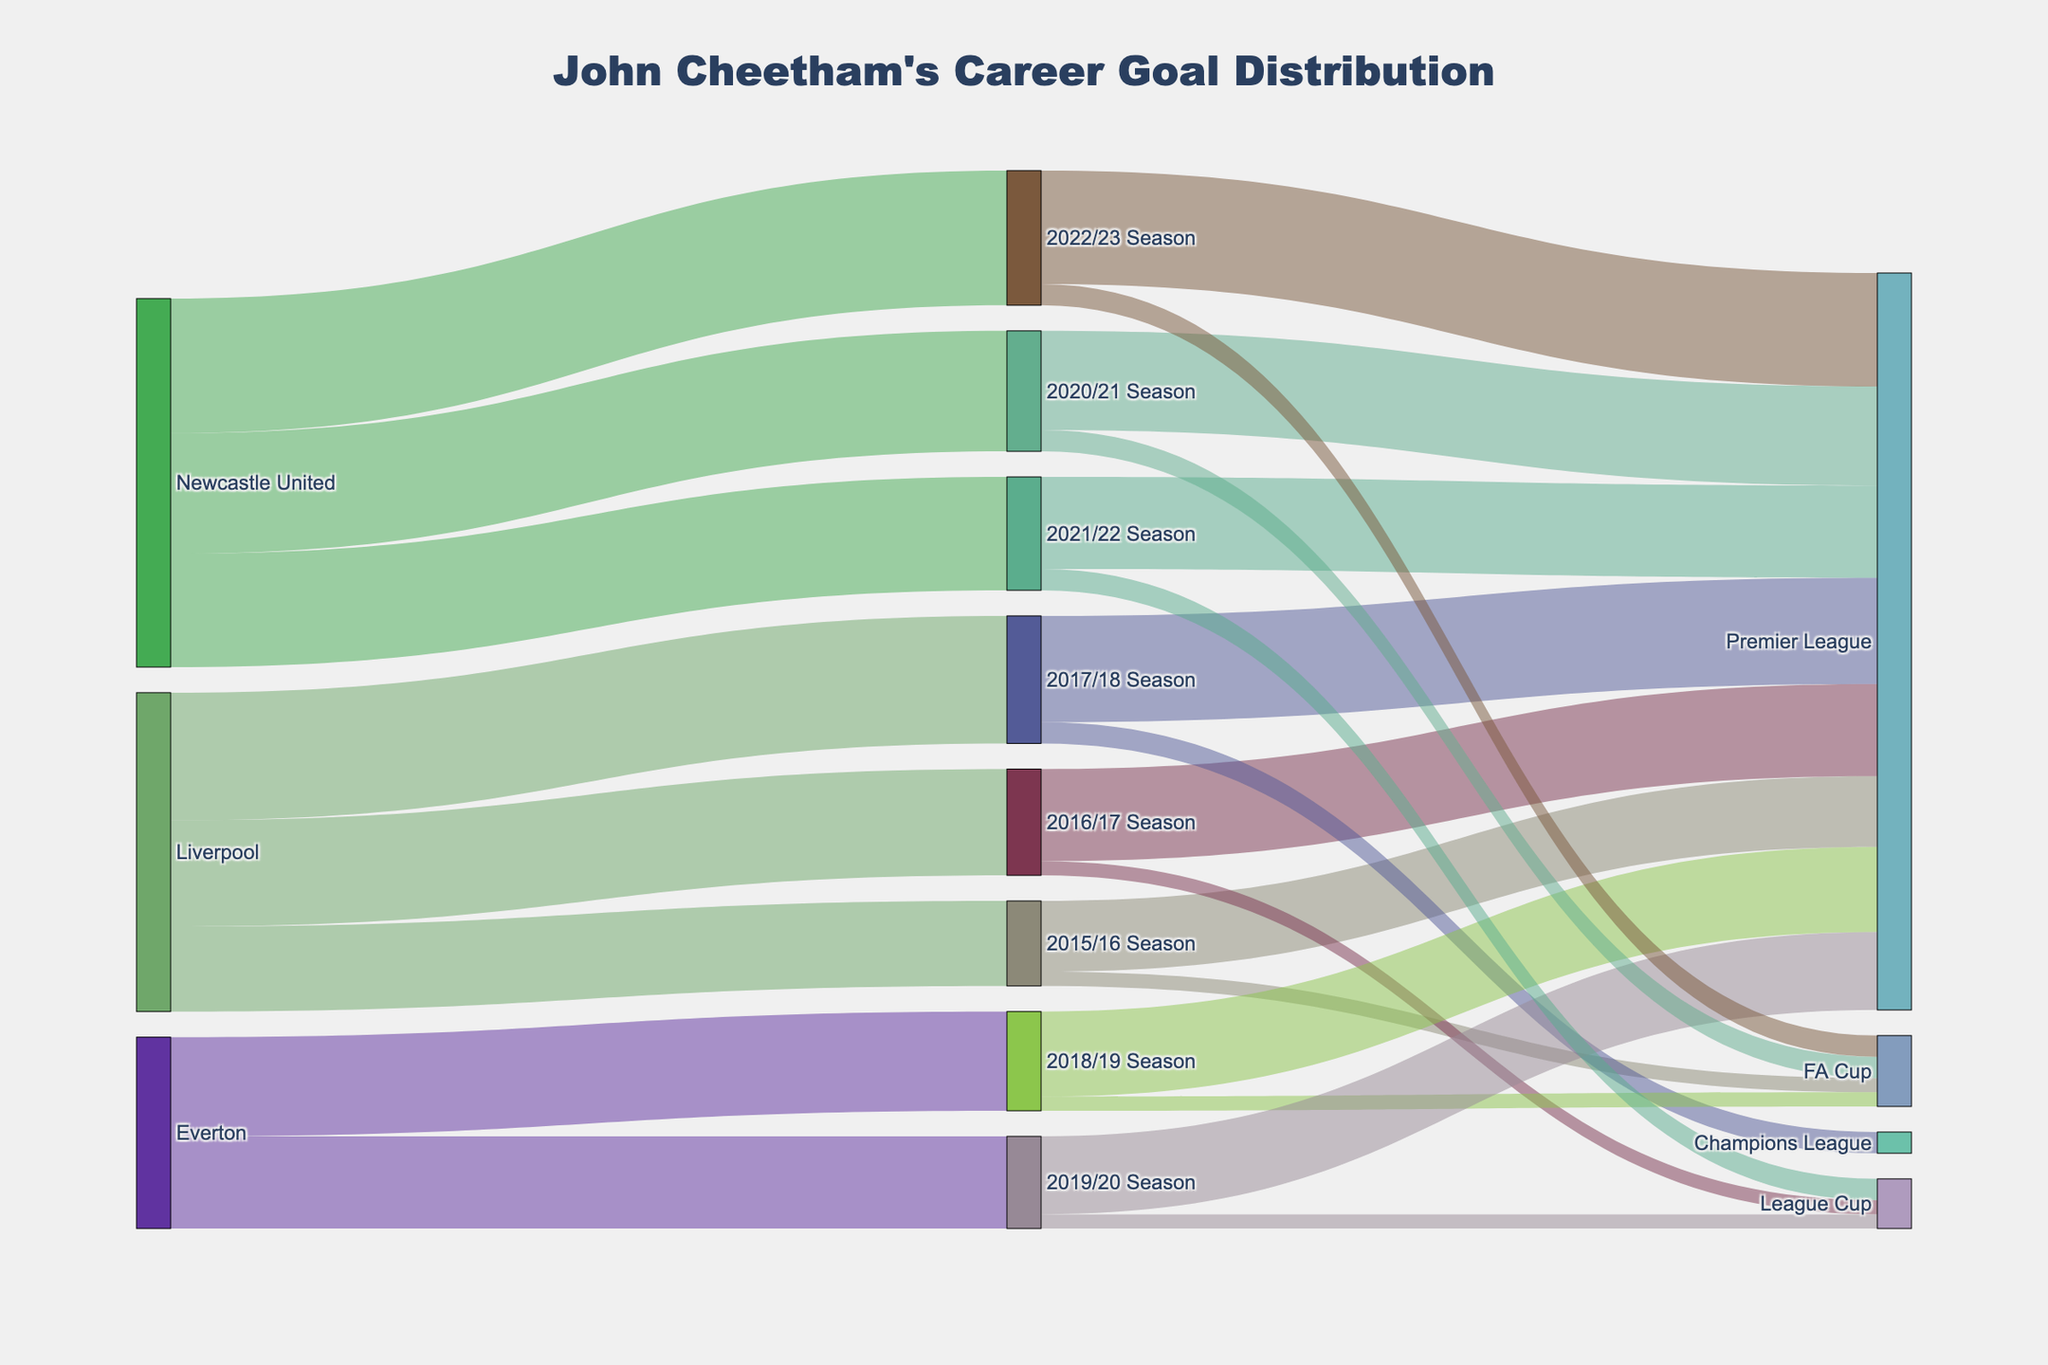What is the title of the Sankey Diagram? The title is usually found at the top of the figure. In this case, it is the main descriptor of the plot.
Answer: John Cheetham's Career Goal Distribution How many goals did John Cheetham score for Liverpool in the 2017/18 season? Referring to the specific flow from Liverpool to the 2017/18 season in the Sankey Diagram, the value indicated is 18 goals.
Answer: 18 Which season did John Cheetham score the highest number of Premier League goals? The Sankey Diagram shows the flows from seasons to different competitions. By looking for the highest value going to the Premier League from each season’s node, you find that the 2022/23 Season has the highest value with 16 goals.
Answer: 2022/23 Season How many total goals did John Cheetham score during his time with Everton? Sum the goals from the nodes Everton to the 2018/19 and 2019/20 seasons: 14 + 13 = 27 goals.
Answer: 27 In which competition did John Cheetham score the fewest goals in any single season? By noting the flows going to different competitions from each season's node, the smallest values are 2 goals each, in the FA Cup (2015/16 and 2018/19) and League Cup (2016/17 and 2019/20).
Answer: FA Cup (2015/16, 2018/19), League Cup (2016/17, 2019/20) How does the number of FA Cup goals in the 2022/23 season compare to the number of goals in the FA Cup in the 2020/21 season? Locate the flows from 2022/23 Season and 2020/21 Season to the FA Cup node, where the values are 3 goals each. They are equal.
Answer: They are equal What is the average number of goals John Cheetham scored per season across all seasons? Add all the goals across seasons (12 + 15 + 18 + 14 + 13 + 17 + 16 + 19 = 124) and then divide by the number of seasons (8): 124 / 8 = 15.5
Answer: 15.5 How many different teams did John Cheetham play for, according to the diagram? The diagram shows flows from three different team nodes: Liverpool, Everton, and Newcastle United.
Answer: 3 What is the overall trend in John Cheetham's goal-scoring from the 2015/16 season to the 2022/23 season? Observe the changes in goal values for each season; initially increasing, a slight dip during 2018/19 and 2019/20, and then increasing again to a peak at 2022/23.
Answer: Increasing trend with minor dips 